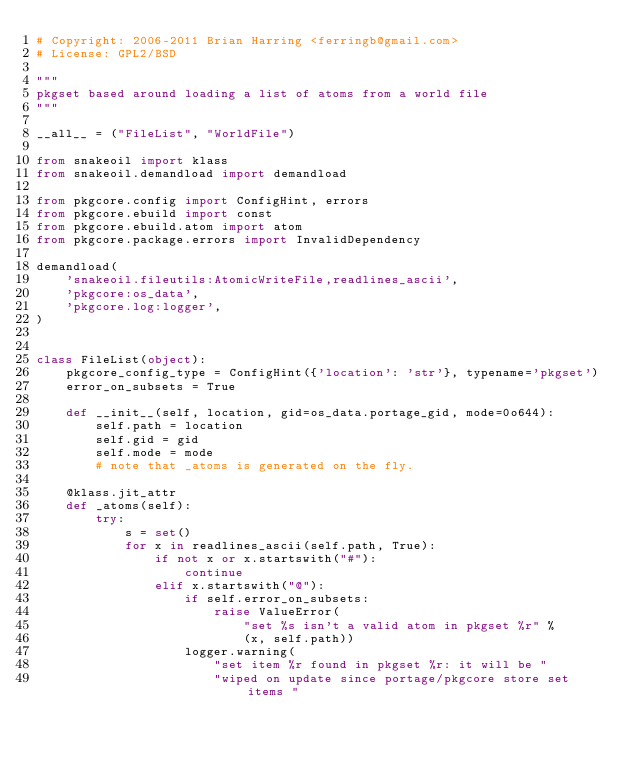Convert code to text. <code><loc_0><loc_0><loc_500><loc_500><_Python_># Copyright: 2006-2011 Brian Harring <ferringb@gmail.com>
# License: GPL2/BSD

"""
pkgset based around loading a list of atoms from a world file
"""

__all__ = ("FileList", "WorldFile")

from snakeoil import klass
from snakeoil.demandload import demandload

from pkgcore.config import ConfigHint, errors
from pkgcore.ebuild import const
from pkgcore.ebuild.atom import atom
from pkgcore.package.errors import InvalidDependency

demandload(
    'snakeoil.fileutils:AtomicWriteFile,readlines_ascii',
    'pkgcore:os_data',
    'pkgcore.log:logger',
)


class FileList(object):
    pkgcore_config_type = ConfigHint({'location': 'str'}, typename='pkgset')
    error_on_subsets = True

    def __init__(self, location, gid=os_data.portage_gid, mode=0o644):
        self.path = location
        self.gid = gid
        self.mode = mode
        # note that _atoms is generated on the fly.

    @klass.jit_attr
    def _atoms(self):
        try:
            s = set()
            for x in readlines_ascii(self.path, True):
                if not x or x.startswith("#"):
                    continue
                elif x.startswith("@"):
                    if self.error_on_subsets:
                        raise ValueError(
                            "set %s isn't a valid atom in pkgset %r" %
                            (x, self.path))
                    logger.warning(
                        "set item %r found in pkgset %r: it will be "
                        "wiped on update since portage/pkgcore store set items "</code> 